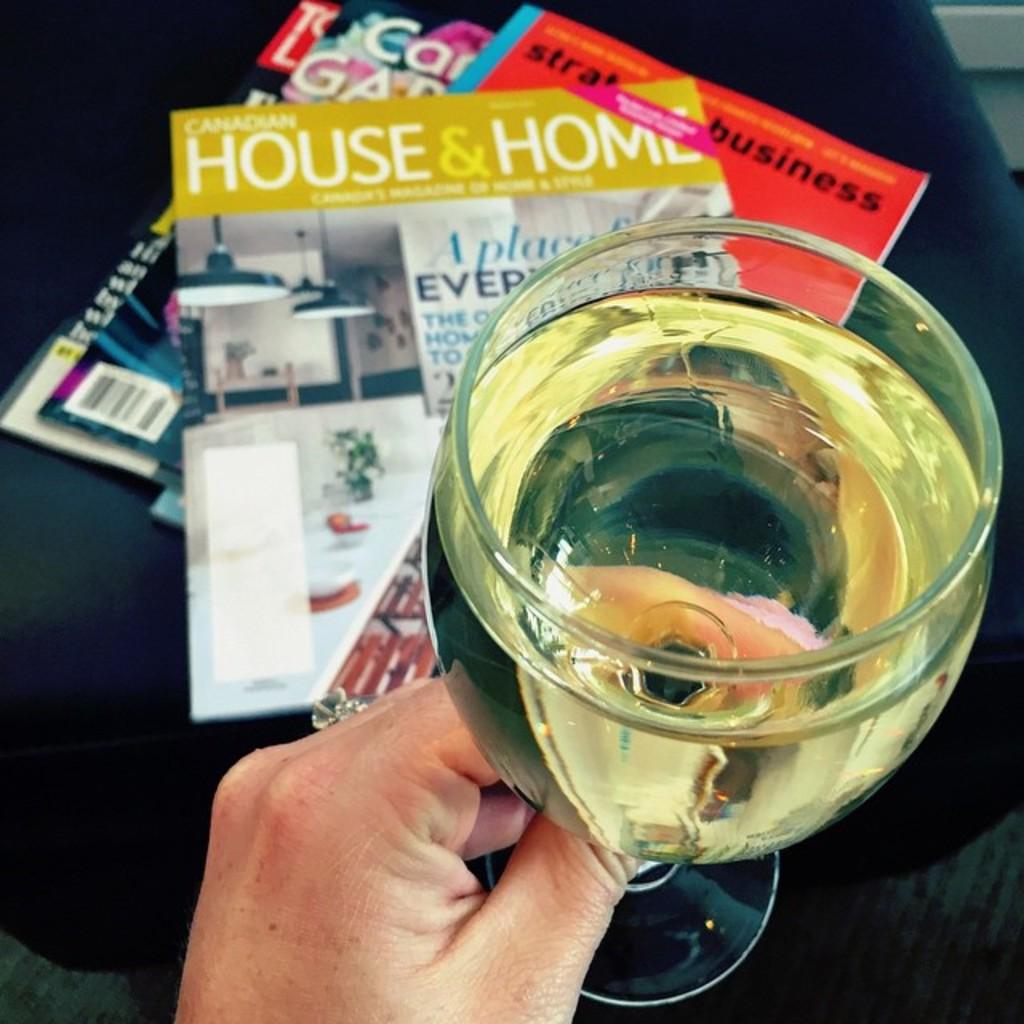What magazine is on top of the stack?
Ensure brevity in your answer.  House & home. What word is visible on the red magazine?
Your response must be concise. Business. 